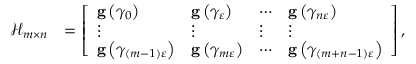Convert formula to latex. <formula><loc_0><loc_0><loc_500><loc_500>\begin{array} { r l } { \mathcal { H } _ { m \times n } } & { = \left [ \begin{array} { l l l l } { g \left ( \gamma _ { 0 } \right ) } & { g \left ( \gamma _ { \varepsilon } \right ) } & { \cdots } & { g \left ( \gamma _ { n \varepsilon } \right ) } \\ { \vdots } & { \vdots } & { \vdots } & { \vdots } \\ { g \left ( \gamma _ { \left ( m - 1 \right ) \varepsilon } \right ) } & { g \left ( \gamma _ { m \varepsilon } \right ) } & { \cdots } & { g \left ( \gamma _ { \left ( m + n - 1 \right ) \varepsilon } \right ) } \end{array} \right ] , } \end{array}</formula> 